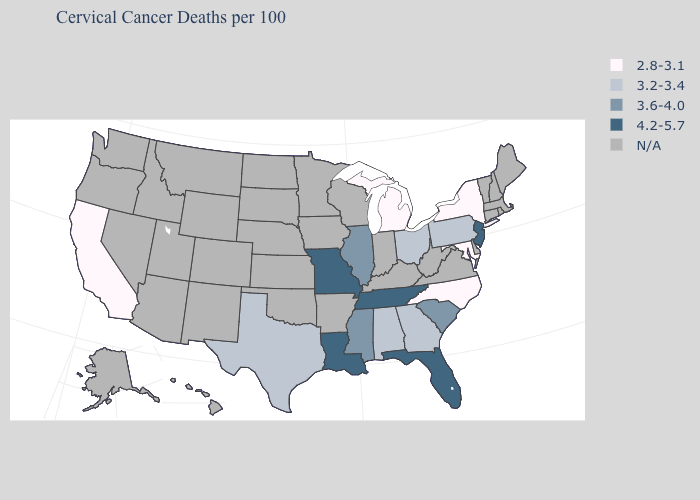What is the lowest value in the MidWest?
Concise answer only. 2.8-3.1. Name the states that have a value in the range 4.2-5.7?
Give a very brief answer. Florida, Louisiana, Missouri, New Jersey, Tennessee. What is the value of Hawaii?
Be succinct. N/A. Does Missouri have the highest value in the USA?
Quick response, please. Yes. What is the value of California?
Concise answer only. 2.8-3.1. Does the first symbol in the legend represent the smallest category?
Be succinct. Yes. Name the states that have a value in the range 3.6-4.0?
Keep it brief. Illinois, Mississippi, South Carolina. Among the states that border South Carolina , which have the lowest value?
Write a very short answer. North Carolina. Name the states that have a value in the range 4.2-5.7?
Give a very brief answer. Florida, Louisiana, Missouri, New Jersey, Tennessee. What is the value of Michigan?
Give a very brief answer. 2.8-3.1. Which states have the lowest value in the USA?
Give a very brief answer. California, Maryland, Michigan, New York, North Carolina. Name the states that have a value in the range 2.8-3.1?
Answer briefly. California, Maryland, Michigan, New York, North Carolina. Name the states that have a value in the range 3.6-4.0?
Answer briefly. Illinois, Mississippi, South Carolina. 